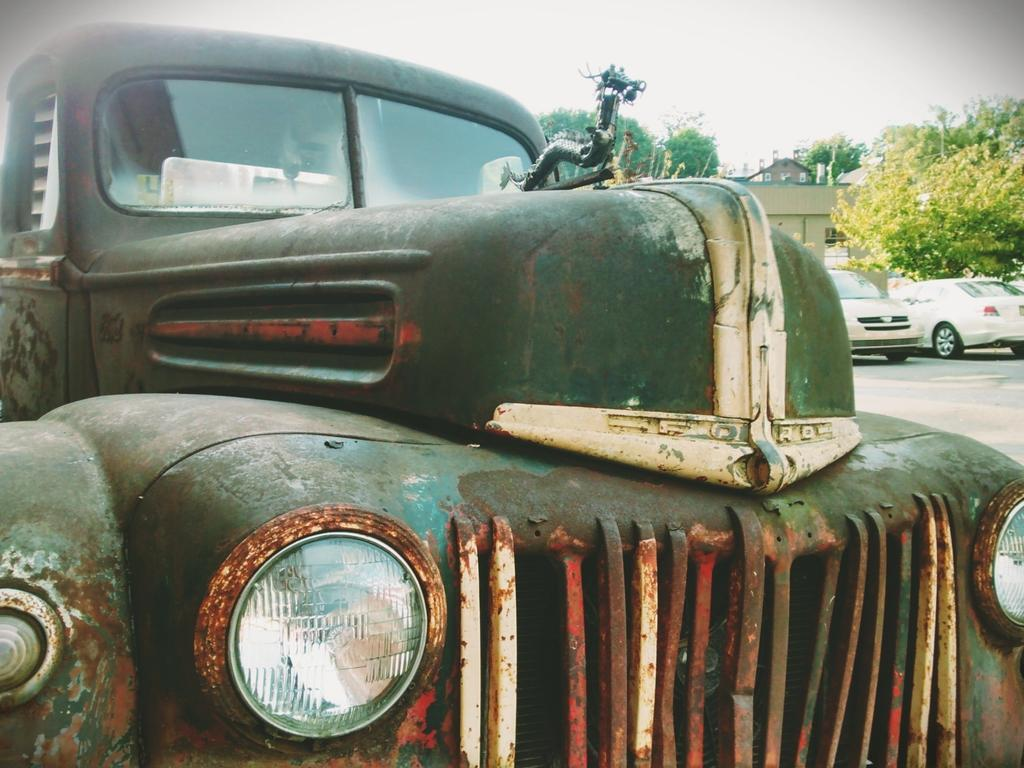What is the main subject of the image? There is a vehicle in the image. What can be seen in the background of the image? There are cars, trees, buildings, and the sky visible in the background of the image. What type of holiday is being celebrated in the image? There is no indication of a holiday being celebrated in the image. What type of humor can be seen in the image? There is no humor present in the image; it is a straightforward depiction of a vehicle and its surroundings. 